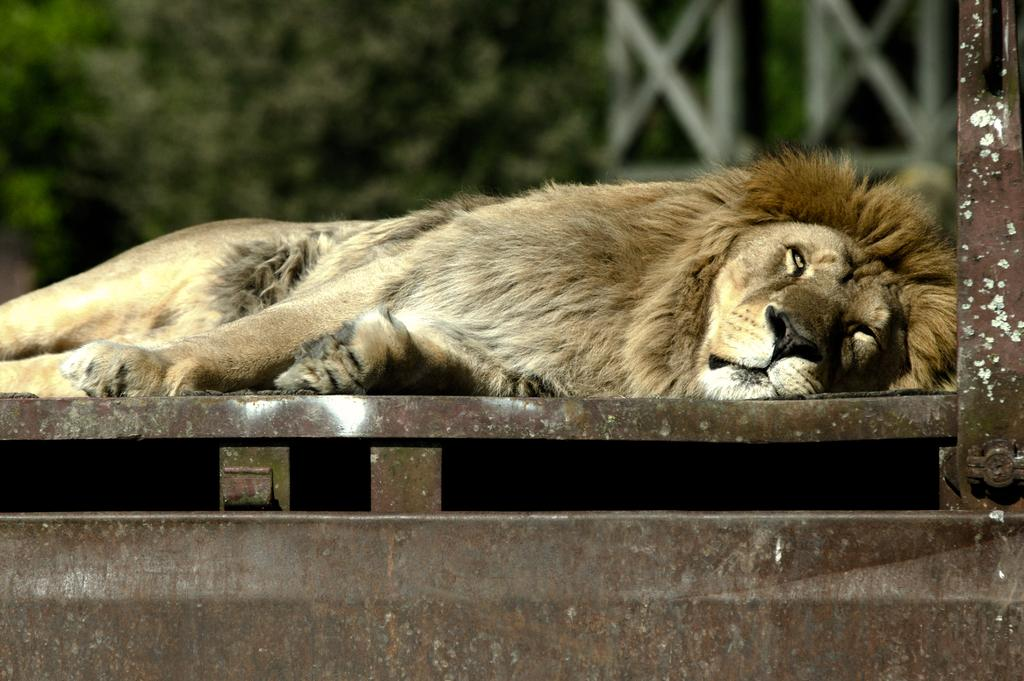What animal is the main subject of the picture? There is a lion in the picture. What is the lion's position in the image? The lion is lying on a platform. What can be seen in the background of the picture? There are trees visible in the background of the picture. How would you describe the background of the image? The background of the image is blurry. What type of pollution can be seen in the image? There is no pollution visible in the image; it features a lion lying on a platform with trees in the background. Who is the lion's partner in the image? The image does not depict a partner for the lion, as it is focused on the lion lying on a platform. 